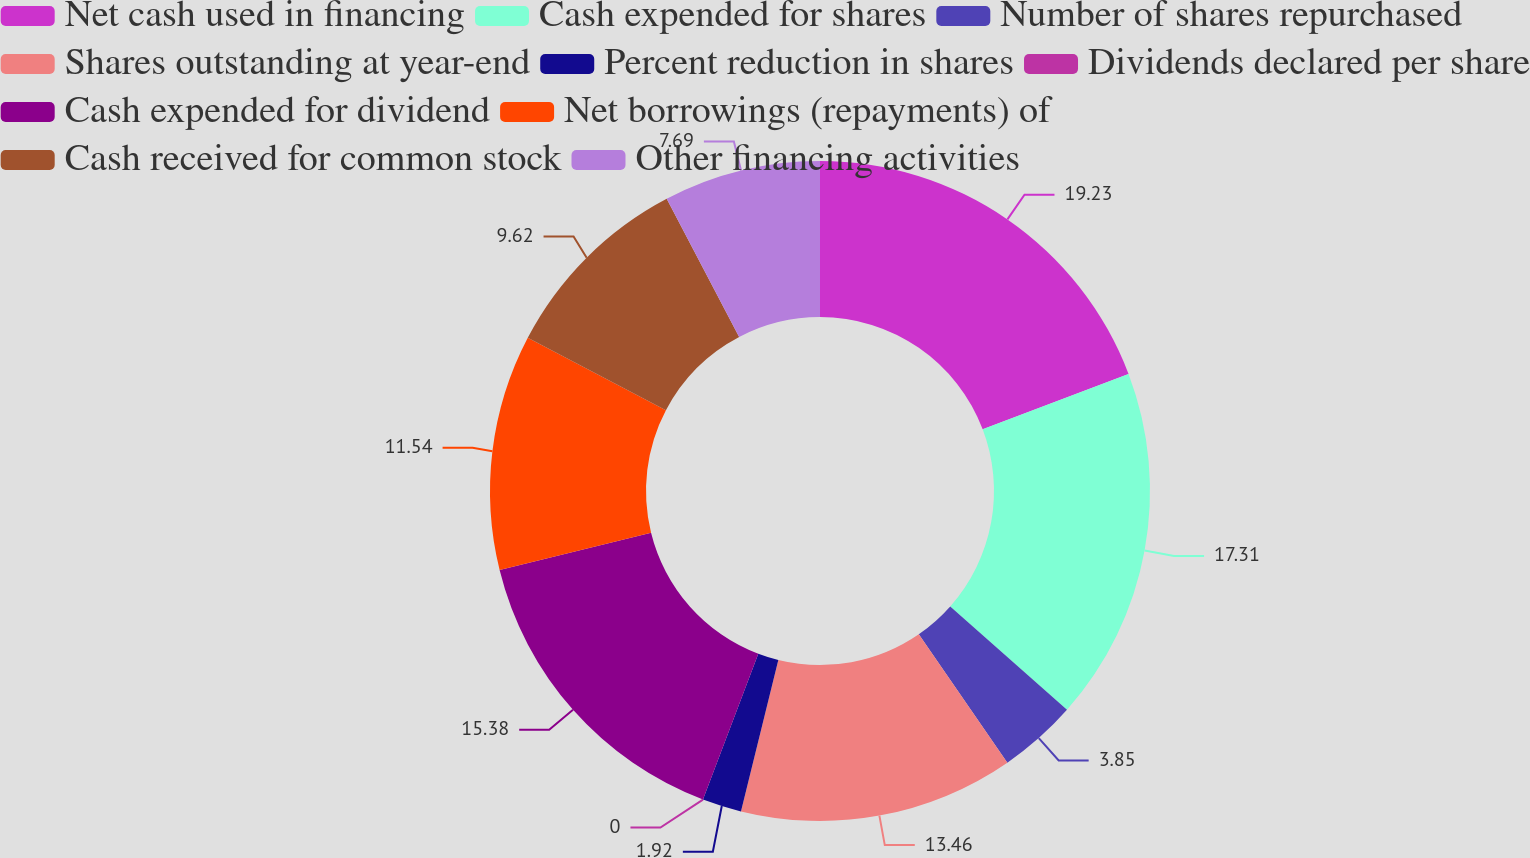Convert chart to OTSL. <chart><loc_0><loc_0><loc_500><loc_500><pie_chart><fcel>Net cash used in financing<fcel>Cash expended for shares<fcel>Number of shares repurchased<fcel>Shares outstanding at year-end<fcel>Percent reduction in shares<fcel>Dividends declared per share<fcel>Cash expended for dividend<fcel>Net borrowings (repayments) of<fcel>Cash received for common stock<fcel>Other financing activities<nl><fcel>19.23%<fcel>17.31%<fcel>3.85%<fcel>13.46%<fcel>1.92%<fcel>0.0%<fcel>15.38%<fcel>11.54%<fcel>9.62%<fcel>7.69%<nl></chart> 